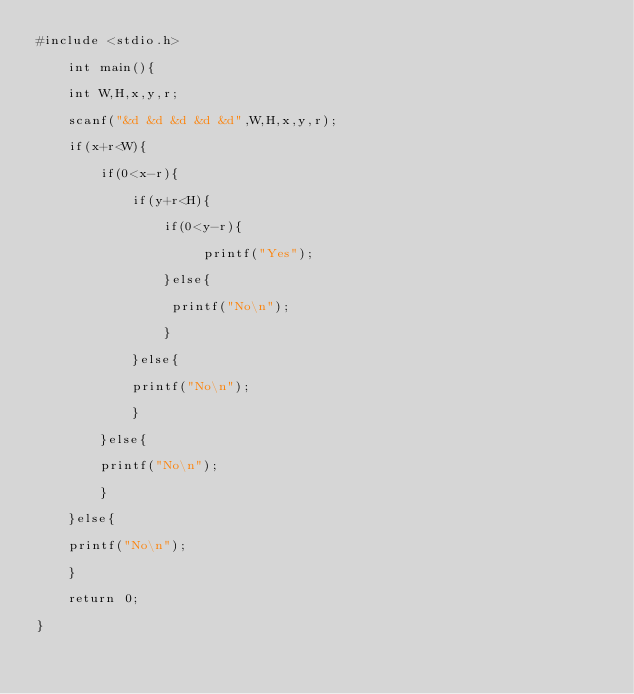Convert code to text. <code><loc_0><loc_0><loc_500><loc_500><_C_>#include <stdio.h>

    int main(){

    int W,H,x,y,r;

    scanf("&d &d &d &d &d",W,H,x,y,r);

    if(x+r<W){

        if(0<x-r){

            if(y+r<H){

                if(0<y-r){

                     printf("Yes");

                }else{

                 printf("No\n");

                }

            }else{

            printf("No\n");

            }

        }else{

        printf("No\n");

        }

    }else{

    printf("No\n");

    }

    return 0;

} 
</code> 